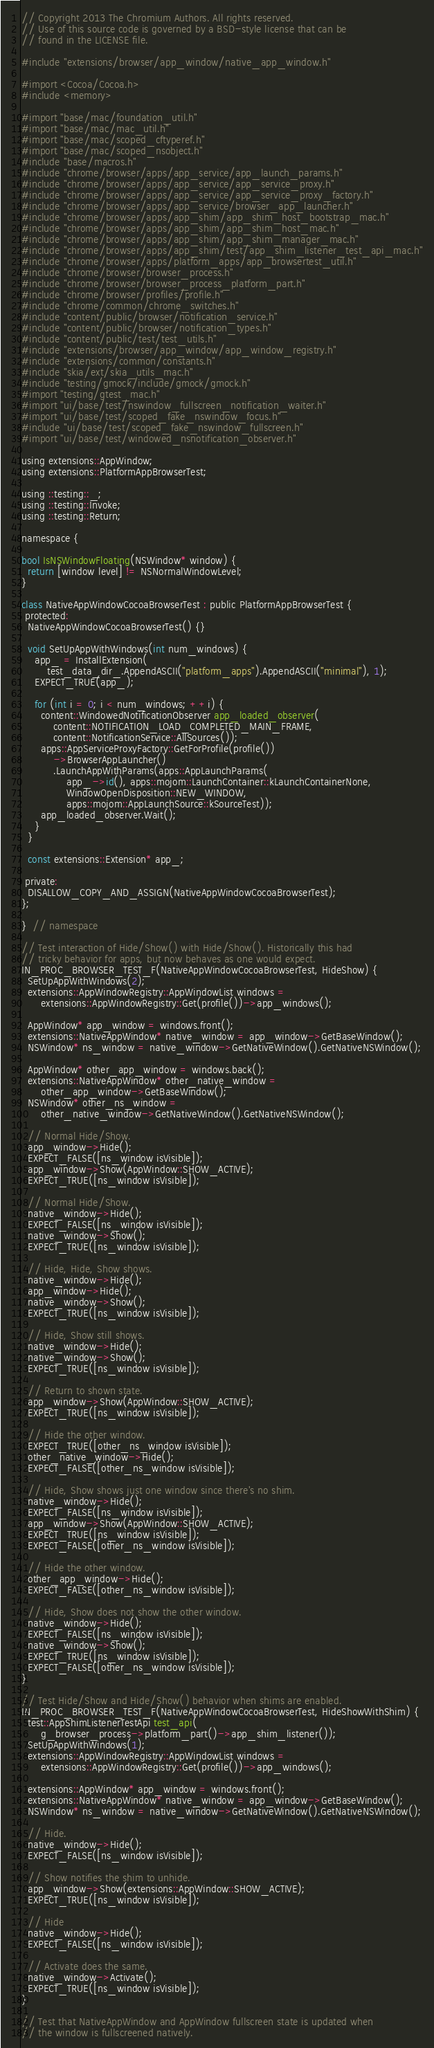Convert code to text. <code><loc_0><loc_0><loc_500><loc_500><_ObjectiveC_>// Copyright 2013 The Chromium Authors. All rights reserved.
// Use of this source code is governed by a BSD-style license that can be
// found in the LICENSE file.

#include "extensions/browser/app_window/native_app_window.h"

#import <Cocoa/Cocoa.h>
#include <memory>

#import "base/mac/foundation_util.h"
#import "base/mac/mac_util.h"
#import "base/mac/scoped_cftyperef.h"
#import "base/mac/scoped_nsobject.h"
#include "base/macros.h"
#include "chrome/browser/apps/app_service/app_launch_params.h"
#include "chrome/browser/apps/app_service/app_service_proxy.h"
#include "chrome/browser/apps/app_service/app_service_proxy_factory.h"
#include "chrome/browser/apps/app_service/browser_app_launcher.h"
#include "chrome/browser/apps/app_shim/app_shim_host_bootstrap_mac.h"
#include "chrome/browser/apps/app_shim/app_shim_host_mac.h"
#include "chrome/browser/apps/app_shim/app_shim_manager_mac.h"
#include "chrome/browser/apps/app_shim/test/app_shim_listener_test_api_mac.h"
#include "chrome/browser/apps/platform_apps/app_browsertest_util.h"
#include "chrome/browser/browser_process.h"
#include "chrome/browser/browser_process_platform_part.h"
#include "chrome/browser/profiles/profile.h"
#include "chrome/common/chrome_switches.h"
#include "content/public/browser/notification_service.h"
#include "content/public/browser/notification_types.h"
#include "content/public/test/test_utils.h"
#include "extensions/browser/app_window/app_window_registry.h"
#include "extensions/common/constants.h"
#include "skia/ext/skia_utils_mac.h"
#include "testing/gmock/include/gmock/gmock.h"
#import "testing/gtest_mac.h"
#import "ui/base/test/nswindow_fullscreen_notification_waiter.h"
#import "ui/base/test/scoped_fake_nswindow_focus.h"
#include "ui/base/test/scoped_fake_nswindow_fullscreen.h"
#import "ui/base/test/windowed_nsnotification_observer.h"

using extensions::AppWindow;
using extensions::PlatformAppBrowserTest;

using ::testing::_;
using ::testing::Invoke;
using ::testing::Return;

namespace {

bool IsNSWindowFloating(NSWindow* window) {
  return [window level] != NSNormalWindowLevel;
}

class NativeAppWindowCocoaBrowserTest : public PlatformAppBrowserTest {
 protected:
  NativeAppWindowCocoaBrowserTest() {}

  void SetUpAppWithWindows(int num_windows) {
    app_ = InstallExtension(
        test_data_dir_.AppendASCII("platform_apps").AppendASCII("minimal"), 1);
    EXPECT_TRUE(app_);

    for (int i = 0; i < num_windows; ++i) {
      content::WindowedNotificationObserver app_loaded_observer(
          content::NOTIFICATION_LOAD_COMPLETED_MAIN_FRAME,
          content::NotificationService::AllSources());
      apps::AppServiceProxyFactory::GetForProfile(profile())
          ->BrowserAppLauncher()
          .LaunchAppWithParams(apps::AppLaunchParams(
              app_->id(), apps::mojom::LaunchContainer::kLaunchContainerNone,
              WindowOpenDisposition::NEW_WINDOW,
              apps::mojom::AppLaunchSource::kSourceTest));
      app_loaded_observer.Wait();
    }
  }

  const extensions::Extension* app_;

 private:
  DISALLOW_COPY_AND_ASSIGN(NativeAppWindowCocoaBrowserTest);
};

}  // namespace

// Test interaction of Hide/Show() with Hide/Show(). Historically this had
// tricky behavior for apps, but now behaves as one would expect.
IN_PROC_BROWSER_TEST_F(NativeAppWindowCocoaBrowserTest, HideShow) {
  SetUpAppWithWindows(2);
  extensions::AppWindowRegistry::AppWindowList windows =
      extensions::AppWindowRegistry::Get(profile())->app_windows();

  AppWindow* app_window = windows.front();
  extensions::NativeAppWindow* native_window = app_window->GetBaseWindow();
  NSWindow* ns_window = native_window->GetNativeWindow().GetNativeNSWindow();

  AppWindow* other_app_window = windows.back();
  extensions::NativeAppWindow* other_native_window =
      other_app_window->GetBaseWindow();
  NSWindow* other_ns_window =
      other_native_window->GetNativeWindow().GetNativeNSWindow();

  // Normal Hide/Show.
  app_window->Hide();
  EXPECT_FALSE([ns_window isVisible]);
  app_window->Show(AppWindow::SHOW_ACTIVE);
  EXPECT_TRUE([ns_window isVisible]);

  // Normal Hide/Show.
  native_window->Hide();
  EXPECT_FALSE([ns_window isVisible]);
  native_window->Show();
  EXPECT_TRUE([ns_window isVisible]);

  // Hide, Hide, Show shows.
  native_window->Hide();
  app_window->Hide();
  native_window->Show();
  EXPECT_TRUE([ns_window isVisible]);

  // Hide, Show still shows.
  native_window->Hide();
  native_window->Show();
  EXPECT_TRUE([ns_window isVisible]);

  // Return to shown state.
  app_window->Show(AppWindow::SHOW_ACTIVE);
  EXPECT_TRUE([ns_window isVisible]);

  // Hide the other window.
  EXPECT_TRUE([other_ns_window isVisible]);
  other_native_window->Hide();
  EXPECT_FALSE([other_ns_window isVisible]);

  // Hide, Show shows just one window since there's no shim.
  native_window->Hide();
  EXPECT_FALSE([ns_window isVisible]);
  app_window->Show(AppWindow::SHOW_ACTIVE);
  EXPECT_TRUE([ns_window isVisible]);
  EXPECT_FALSE([other_ns_window isVisible]);

  // Hide the other window.
  other_app_window->Hide();
  EXPECT_FALSE([other_ns_window isVisible]);

  // Hide, Show does not show the other window.
  native_window->Hide();
  EXPECT_FALSE([ns_window isVisible]);
  native_window->Show();
  EXPECT_TRUE([ns_window isVisible]);
  EXPECT_FALSE([other_ns_window isVisible]);
}

// Test Hide/Show and Hide/Show() behavior when shims are enabled.
IN_PROC_BROWSER_TEST_F(NativeAppWindowCocoaBrowserTest, HideShowWithShim) {
  test::AppShimListenerTestApi test_api(
      g_browser_process->platform_part()->app_shim_listener());
  SetUpAppWithWindows(1);
  extensions::AppWindowRegistry::AppWindowList windows =
      extensions::AppWindowRegistry::Get(profile())->app_windows();

  extensions::AppWindow* app_window = windows.front();
  extensions::NativeAppWindow* native_window = app_window->GetBaseWindow();
  NSWindow* ns_window = native_window->GetNativeWindow().GetNativeNSWindow();

  // Hide.
  native_window->Hide();
  EXPECT_FALSE([ns_window isVisible]);

  // Show notifies the shim to unhide.
  app_window->Show(extensions::AppWindow::SHOW_ACTIVE);
  EXPECT_TRUE([ns_window isVisible]);

  // Hide
  native_window->Hide();
  EXPECT_FALSE([ns_window isVisible]);

  // Activate does the same.
  native_window->Activate();
  EXPECT_TRUE([ns_window isVisible]);
}

// Test that NativeAppWindow and AppWindow fullscreen state is updated when
// the window is fullscreened natively.</code> 